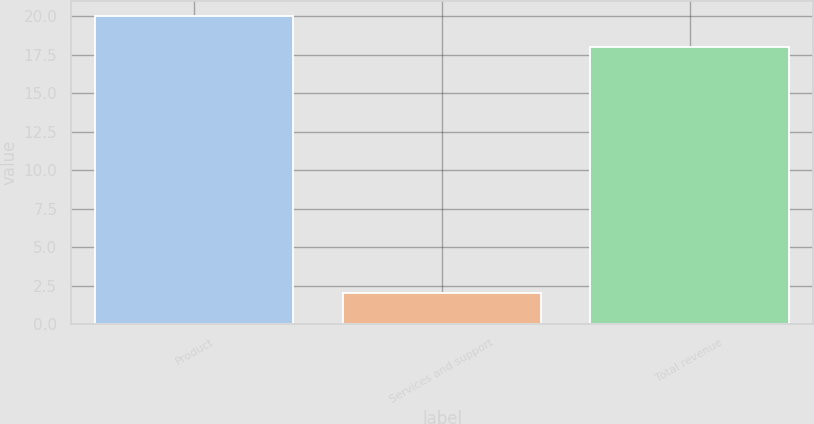<chart> <loc_0><loc_0><loc_500><loc_500><bar_chart><fcel>Product<fcel>Services and support<fcel>Total revenue<nl><fcel>20<fcel>2<fcel>18<nl></chart> 